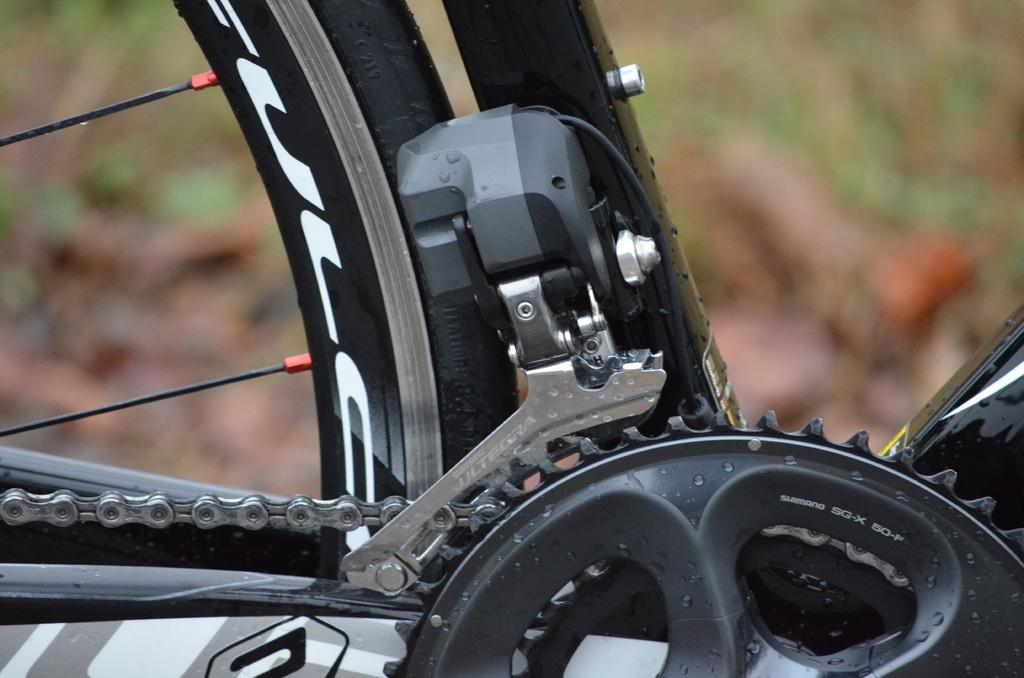What is the main component of the image? There is a bicycle wheel in the image. What part of the bicycle can be seen connected to the wheel? The bicycle chain is visible in the image. What other parts of the bicycle are present in the image? Other devices of the cycle are present in the image. How would you describe the background of the image? The background of the image is blurred. What type of protest is taking place in the image? There is no protest present in the image; it features a bicycle wheel, chain, and other devices. Can you see a hen in the image? There is no hen present in the image. 